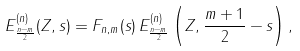<formula> <loc_0><loc_0><loc_500><loc_500>E _ { \frac { n - m } { 2 } } ^ { ( n ) } ( Z , s ) = F _ { n , m } ( s ) \, E _ { \frac { n - m } { 2 } } ^ { ( n ) } \left ( Z , \frac { m + 1 } { 2 } - s \right ) ,</formula> 